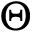<formula> <loc_0><loc_0><loc_500><loc_500>\Theta</formula> 